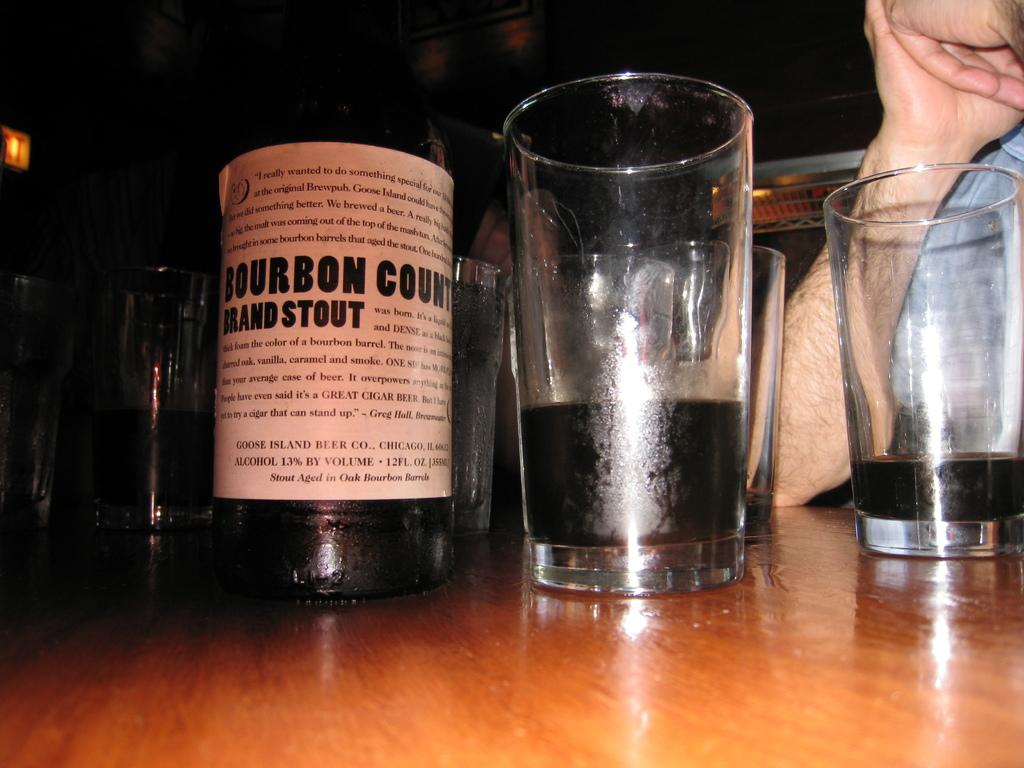Provide a one-sentence caption for the provided image. A bottle of stout sits on a table among partially filled glasses. 